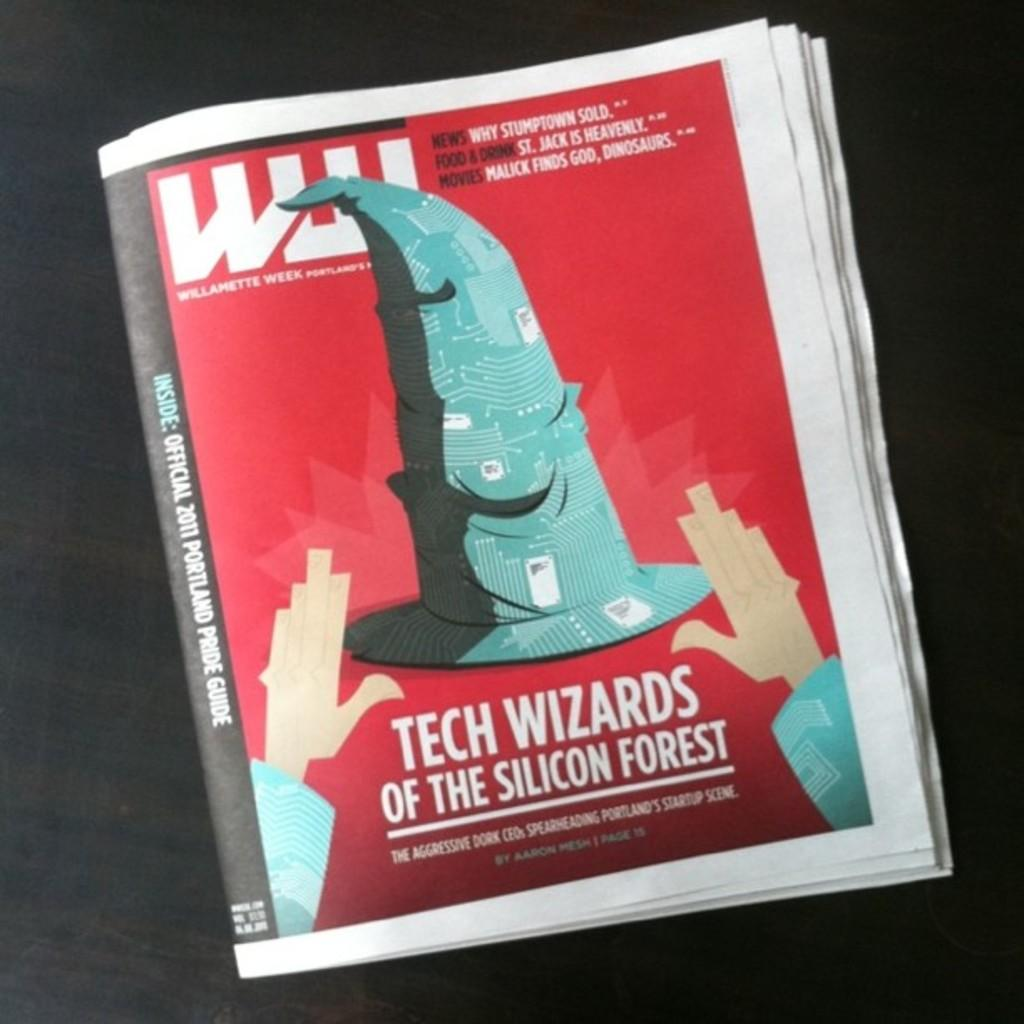<image>
Offer a succinct explanation of the picture presented. A looseleaf newspaper Williamette Week with the cover of Tech Wizards of Silicon Forest 